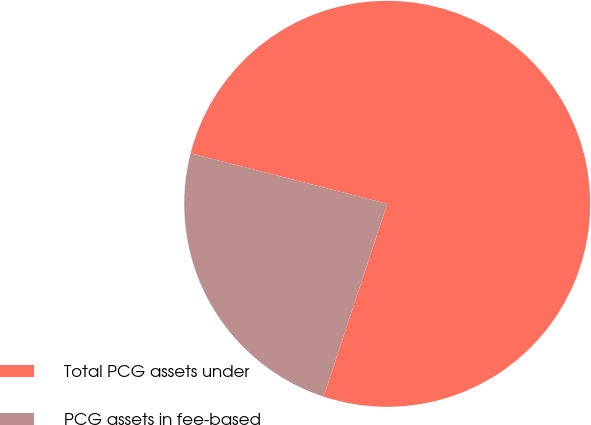Convert chart to OTSL. <chart><loc_0><loc_0><loc_500><loc_500><pie_chart><fcel>Total PCG assets under<fcel>PCG assets in fee-based<nl><fcel>76.07%<fcel>23.93%<nl></chart> 